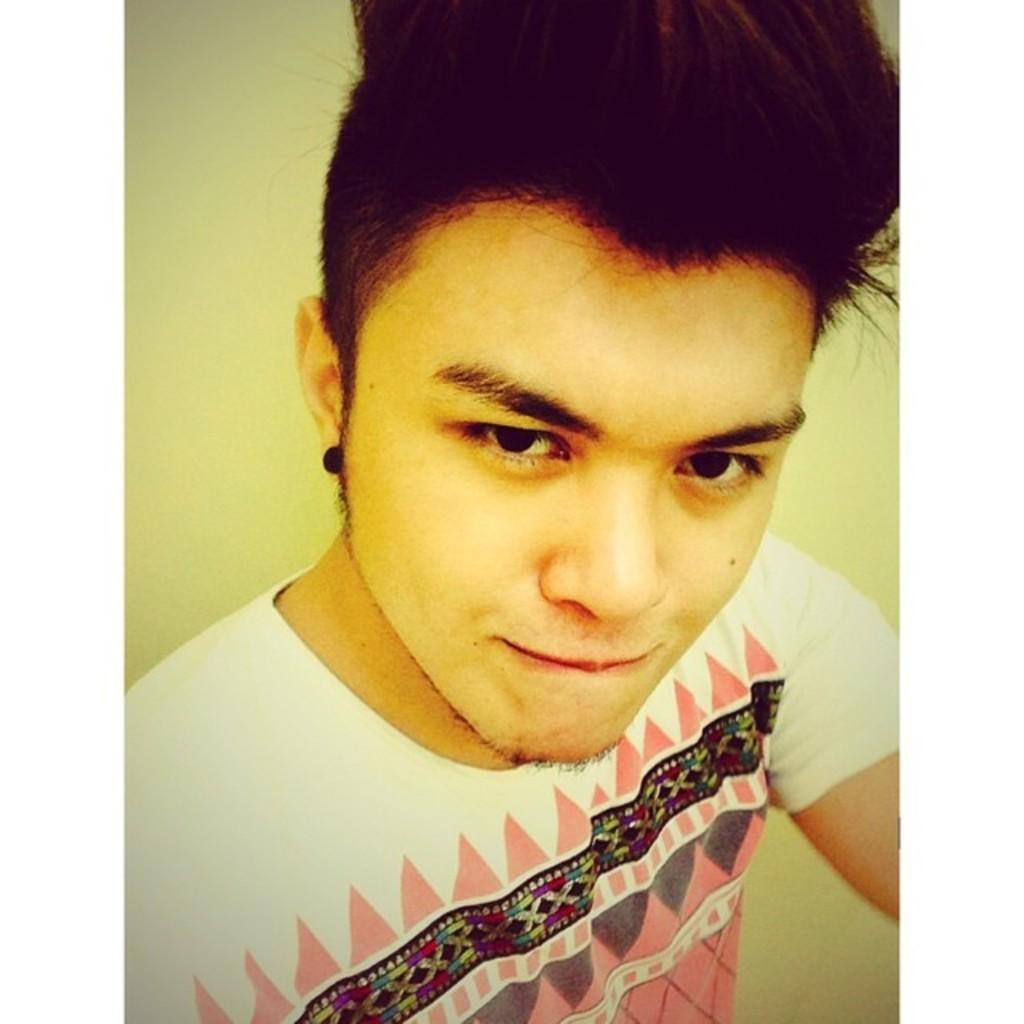Who or what is the main subject in the image? There is a person in the image. What is the person wearing? The person is wearing a white dress. What color is the background of the image? The background of the image is cream-colored. What type of bells can be heard ringing in the image? There are no bells present in the image, and therefore no sound can be heard. Is there a boy visible in the image? The provided facts do not mention the gender of the person in the image, so it cannot be determined if it is a boy or not. 